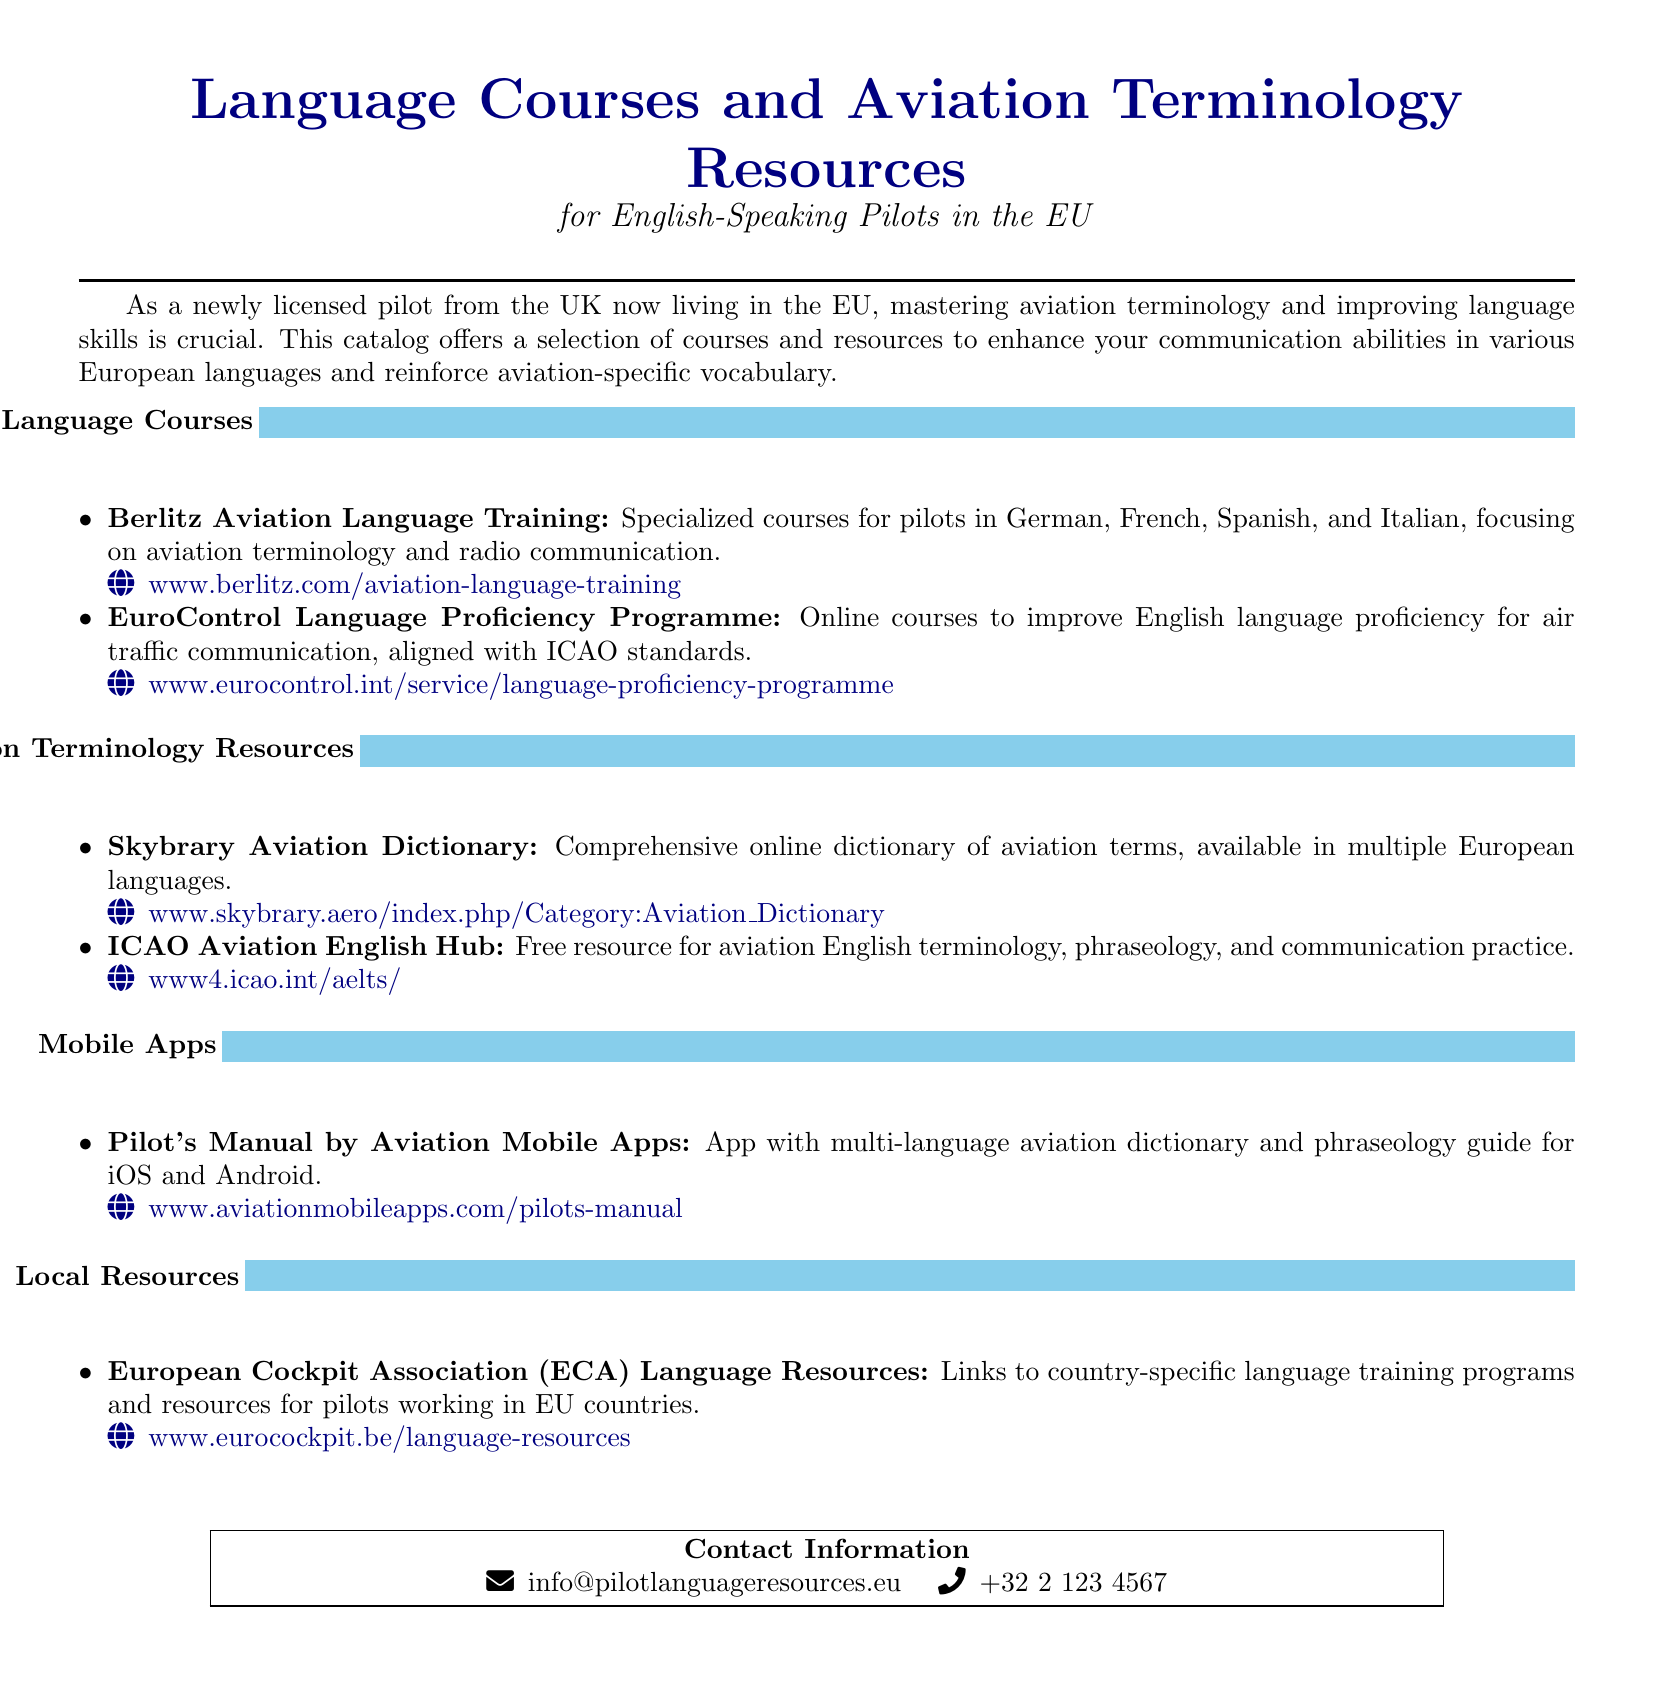What is the title of the document? The title is prominently displayed at the top of the document, indicating the main focus of the catalog.
Answer: Language Courses and Aviation Terminology Resources Which organization offers the Aviation Language Training course? The document lists the providing organization for the course in the language courses section.
Answer: Berlitz How many languages does Berlitz Aviation Language Training cover? The document mentions the specific languages that the course focuses on listed under the language courses section.
Answer: Four What online resource provides a free hub for aviation English terminology? The document specifies the resource that offers free access to aviation English terminology in the aviation terminology resources section.
Answer: ICAO Aviation English Hub What is the contact email provided in the document? The document includes a section for contact information with an email address listed for inquiries.
Answer: info@pilotlanguageresources.eu What mobile app is mentioned for an aviation dictionary? The document specifies the name of the mobile app that contains a multi-language aviation dictionary.
Answer: Pilot's Manual What type of resource is the European Cockpit Association providing? The document describes the nature of the resources offered by the European Cockpit Association in the local resources section.
Answer: Language Resources What is the web address for the EuroControl Language Proficiency Programme? This question asks for the specific URL provided in the language courses section of the document.
Answer: www.eurocontrol.int/service/language-proficiency-programme 